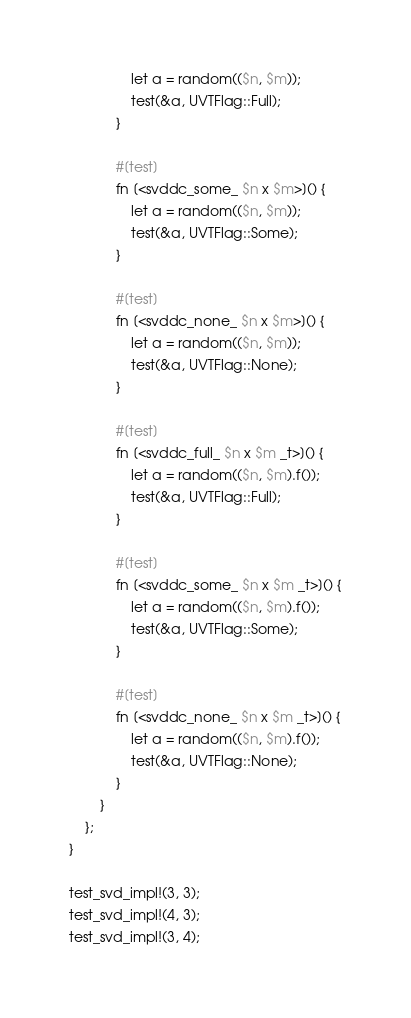Convert code to text. <code><loc_0><loc_0><loc_500><loc_500><_Rust_>                let a = random(($n, $m));
                test(&a, UVTFlag::Full);
            }

            #[test]
            fn [<svddc_some_ $n x $m>]() {
                let a = random(($n, $m));
                test(&a, UVTFlag::Some);
            }

            #[test]
            fn [<svddc_none_ $n x $m>]() {
                let a = random(($n, $m));
                test(&a, UVTFlag::None);
            }

            #[test]
            fn [<svddc_full_ $n x $m _t>]() {
                let a = random(($n, $m).f());
                test(&a, UVTFlag::Full);
            }
            
            #[test]
            fn [<svddc_some_ $n x $m _t>]() {
                let a = random(($n, $m).f());
                test(&a, UVTFlag::Some);
            }

            #[test]
            fn [<svddc_none_ $n x $m _t>]() {
                let a = random(($n, $m).f());
                test(&a, UVTFlag::None);
            }
        }
    };
}

test_svd_impl!(3, 3);
test_svd_impl!(4, 3);
test_svd_impl!(3, 4);
</code> 